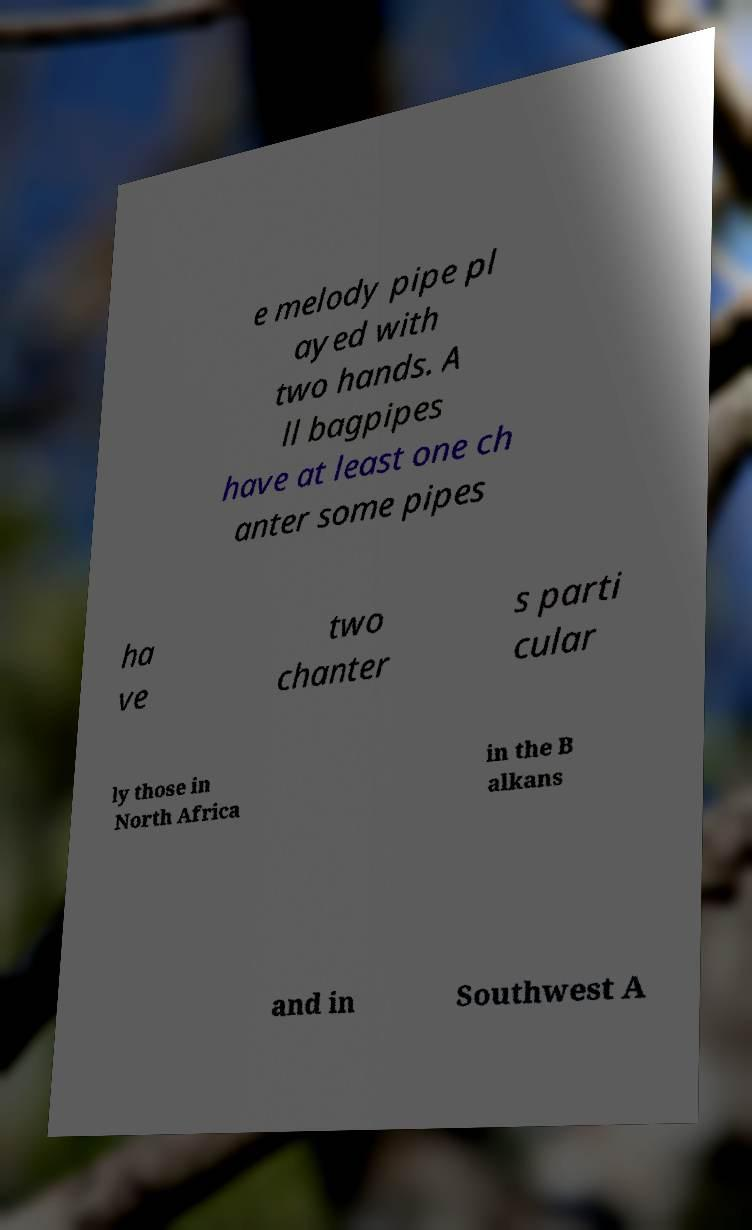I need the written content from this picture converted into text. Can you do that? e melody pipe pl ayed with two hands. A ll bagpipes have at least one ch anter some pipes ha ve two chanter s parti cular ly those in North Africa in the B alkans and in Southwest A 